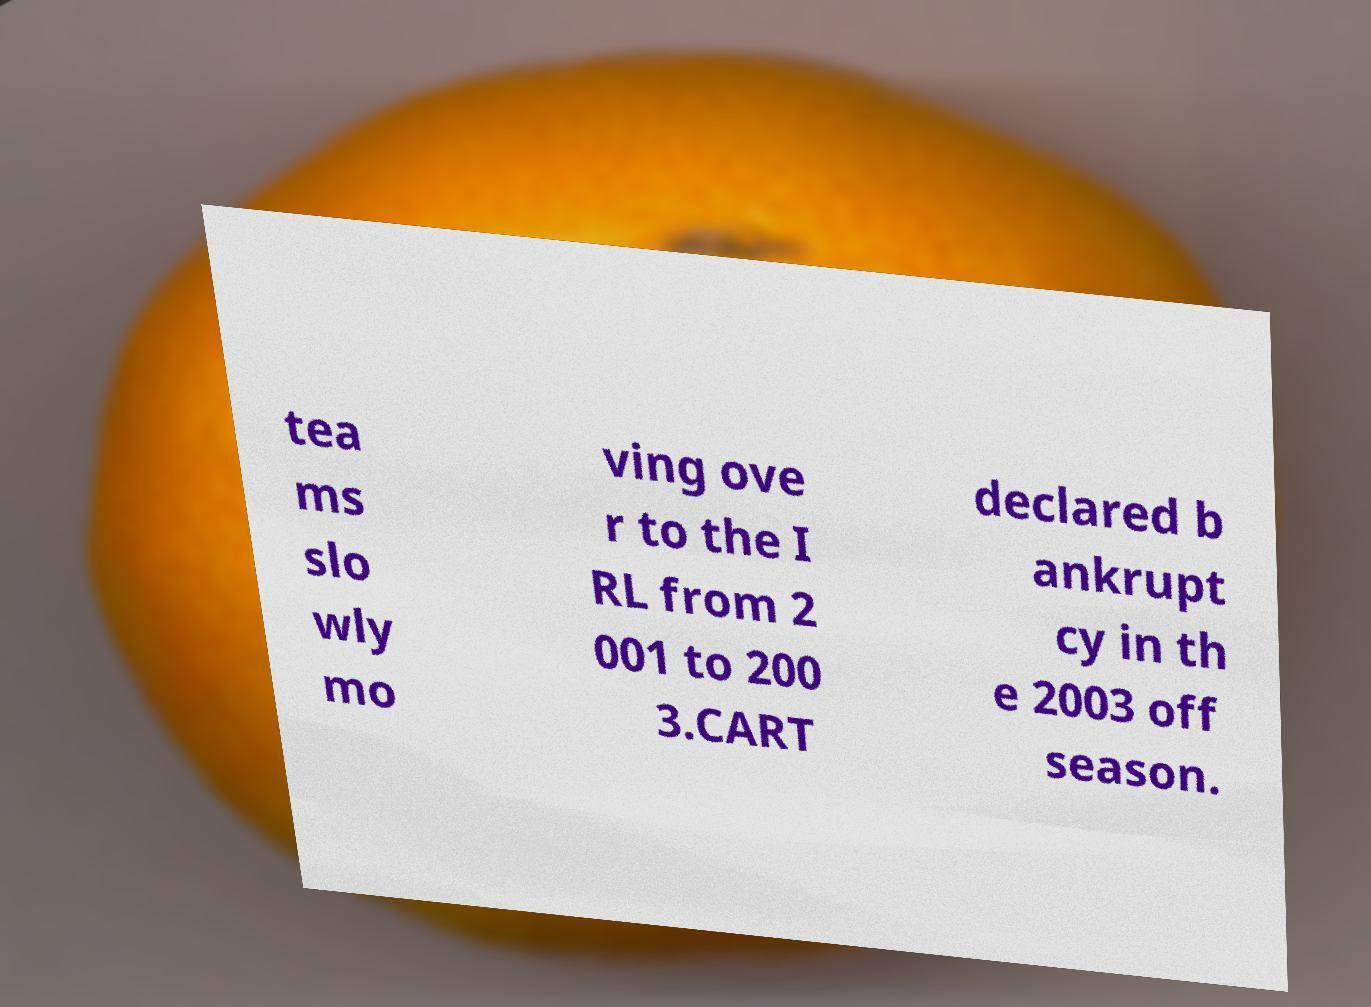For documentation purposes, I need the text within this image transcribed. Could you provide that? tea ms slo wly mo ving ove r to the I RL from 2 001 to 200 3.CART declared b ankrupt cy in th e 2003 off season. 